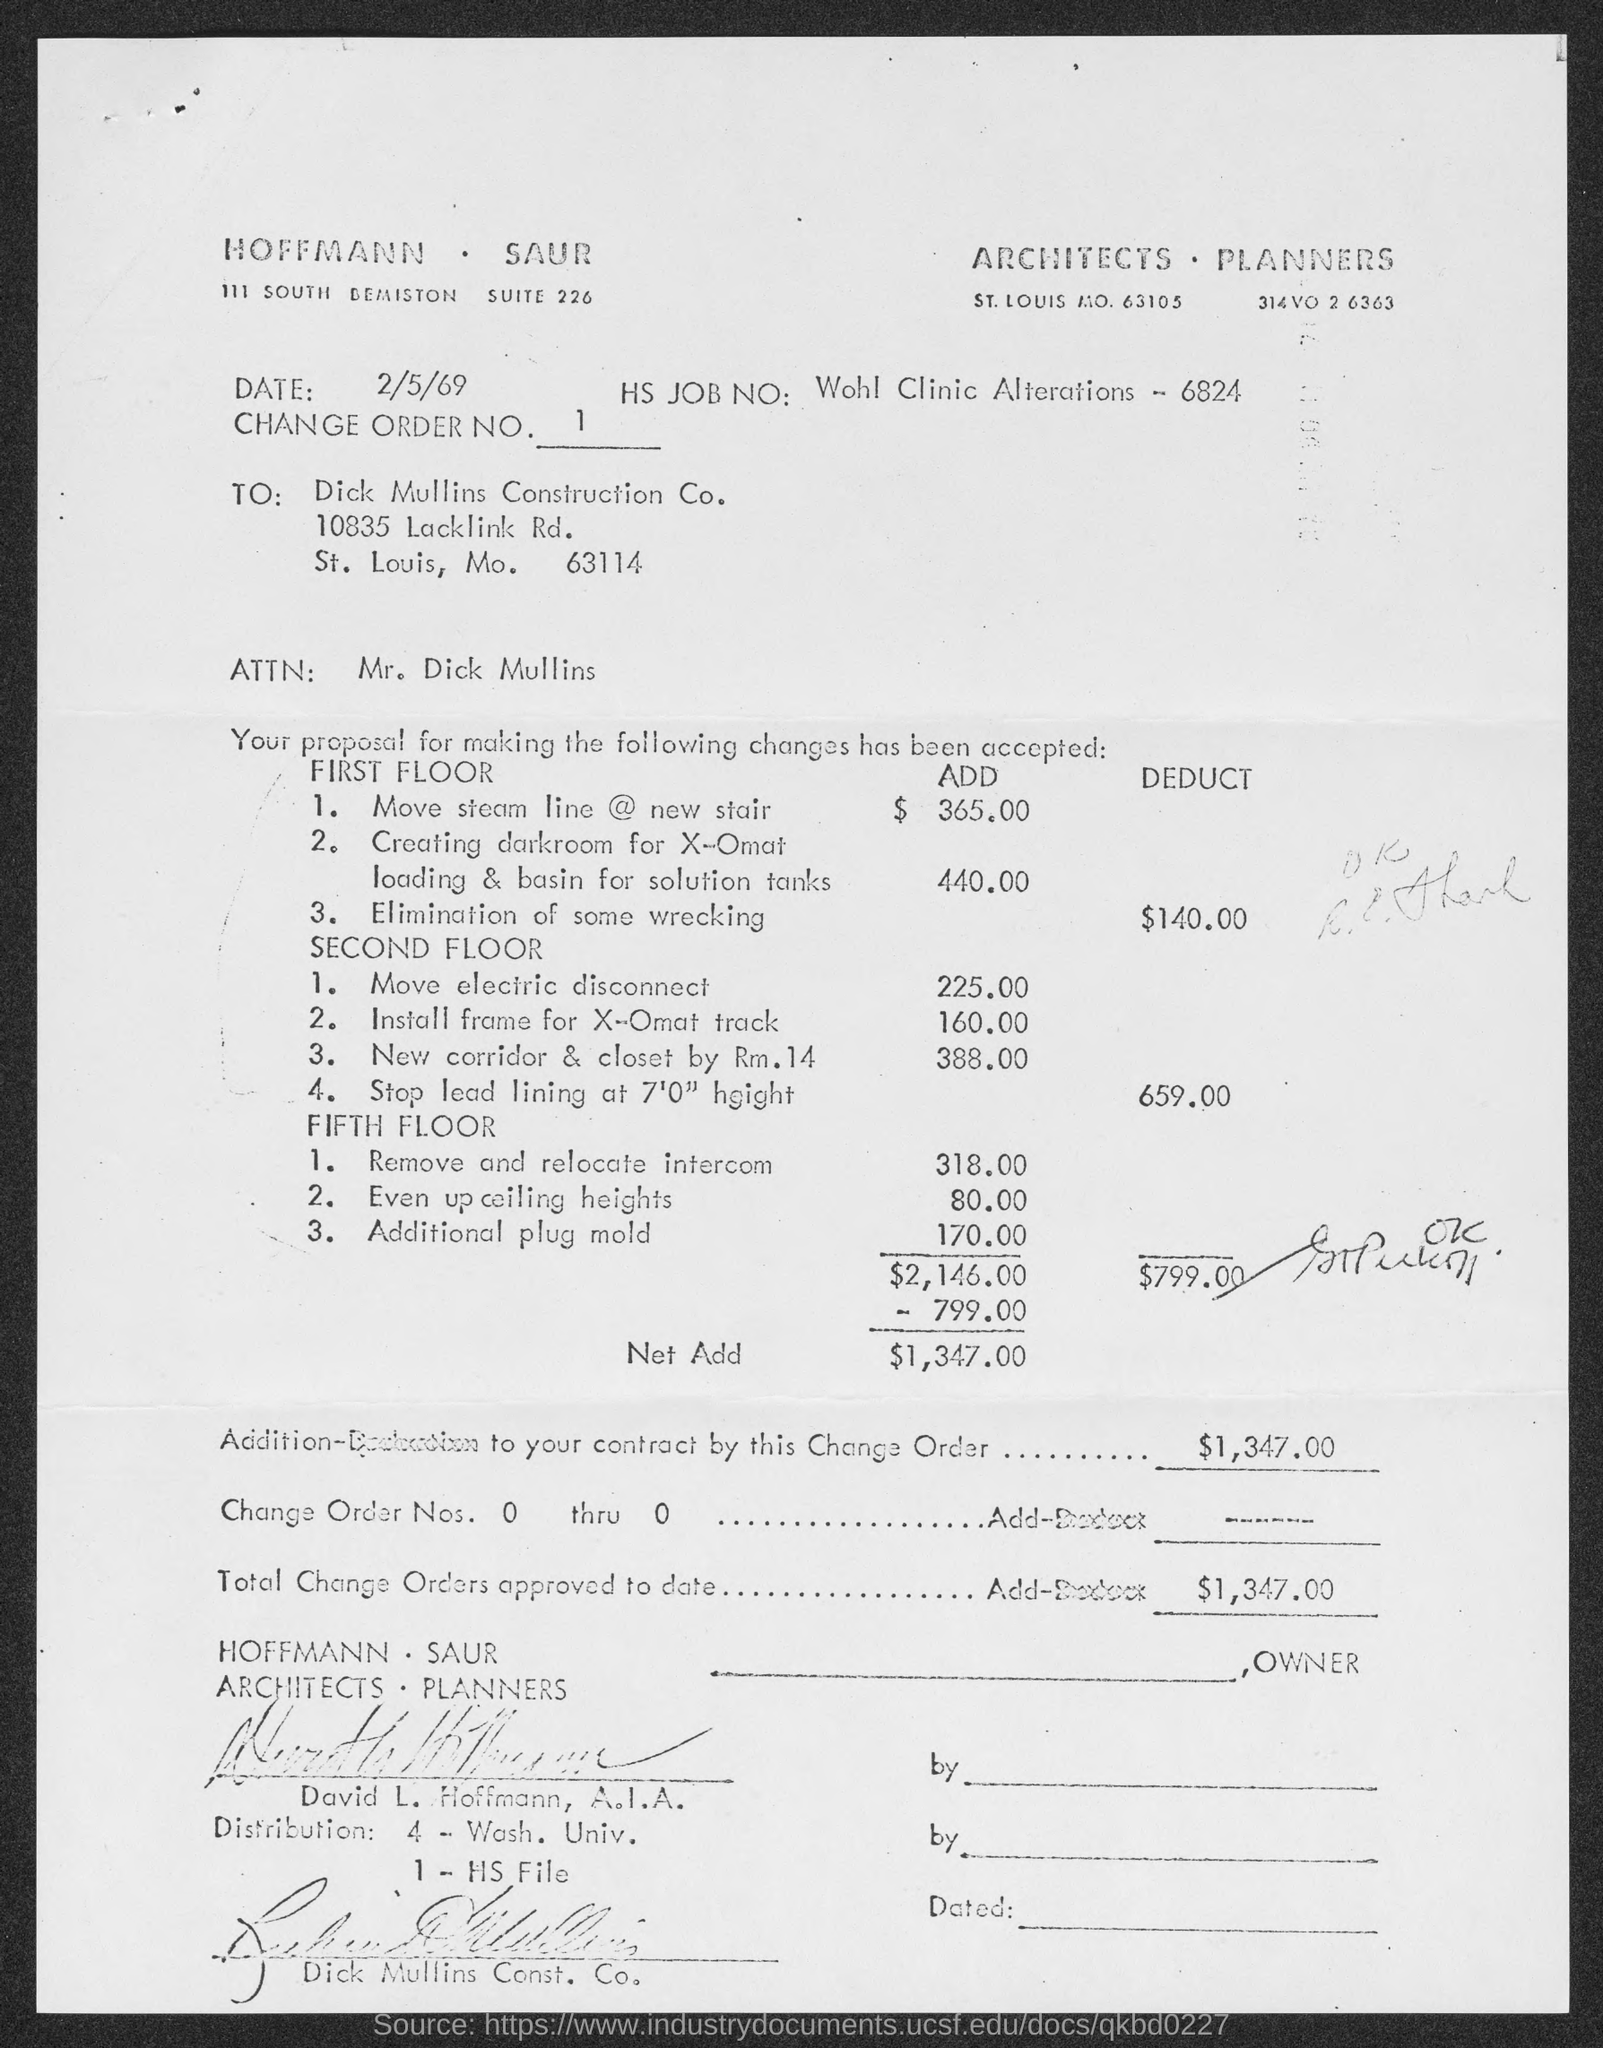What is the SUITE Number ?
Provide a succinct answer. Suite 226. What is the Change order number?
Your answer should be compact. 1. When is the memorandum dated on ?
Provide a short and direct response. 2/5/69. 